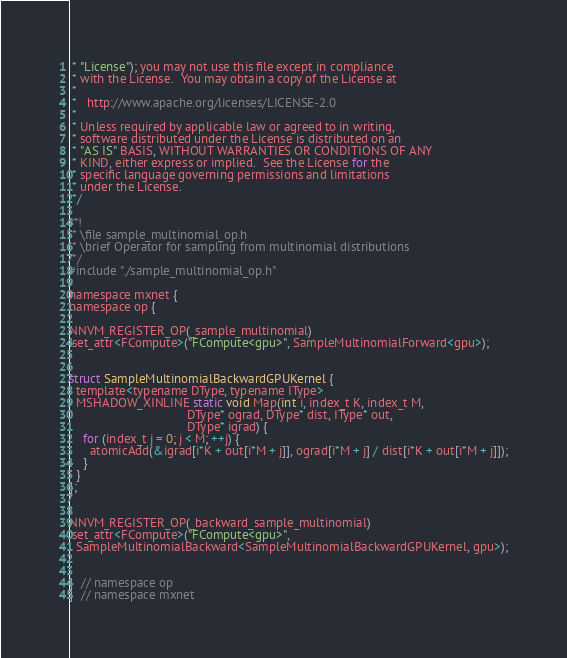Convert code to text. <code><loc_0><loc_0><loc_500><loc_500><_Cuda_> * "License"); you may not use this file except in compliance
 * with the License.  You may obtain a copy of the License at
 *
 *   http://www.apache.org/licenses/LICENSE-2.0
 *
 * Unless required by applicable law or agreed to in writing,
 * software distributed under the License is distributed on an
 * "AS IS" BASIS, WITHOUT WARRANTIES OR CONDITIONS OF ANY
 * KIND, either express or implied.  See the License for the
 * specific language governing permissions and limitations
 * under the License.
 */

/*!
 * \file sample_multinomial_op.h
 * \brief Operator for sampling from multinomial distributions
 */
#include "./sample_multinomial_op.h"

namespace mxnet {
namespace op {

NNVM_REGISTER_OP(_sample_multinomial)
.set_attr<FCompute>("FCompute<gpu>", SampleMultinomialForward<gpu>);


struct SampleMultinomialBackwardGPUKernel {
  template<typename DType, typename IType>
  MSHADOW_XINLINE static void Map(int i, index_t K, index_t M,
                                  DType* ograd, DType* dist, IType* out,
                                  DType* igrad) {
    for (index_t j = 0; j < M; ++j) {
      atomicAdd(&igrad[i*K + out[i*M + j]], ograd[i*M + j] / dist[i*K + out[i*M + j]]);
    }
  }
};


NNVM_REGISTER_OP(_backward_sample_multinomial)
.set_attr<FCompute>("FCompute<gpu>",
  SampleMultinomialBackward<SampleMultinomialBackwardGPUKernel, gpu>);


}  // namespace op
}  // namespace mxnet
</code> 